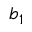Convert formula to latex. <formula><loc_0><loc_0><loc_500><loc_500>b _ { 1 }</formula> 